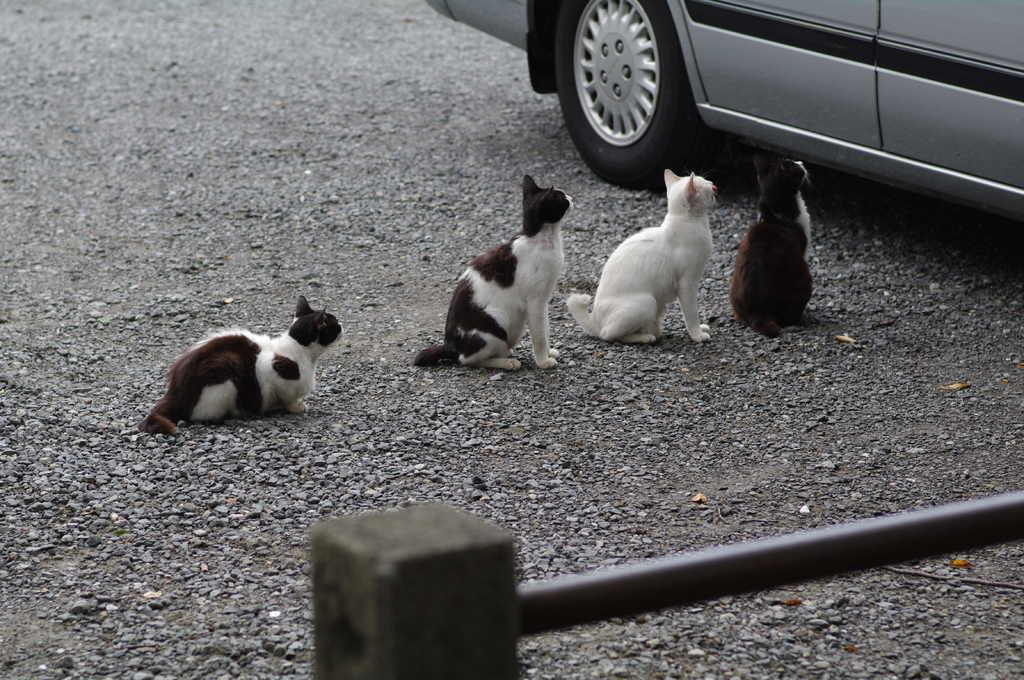What animals can be seen on the ground in the image? There are cats on the ground in the image. What type of natural elements are visible in the image? There are stones visible in the image. What type of vehicle is present in the image? There is a car in the image. What man-made object can be seen in the image? There is a metal pole in the image in the image. Where is the plastic mine located in the image? There is no plastic mine present in the image. What type of note is attached to the metal pole in the image? There is no note attached to the metal pole in the image. 